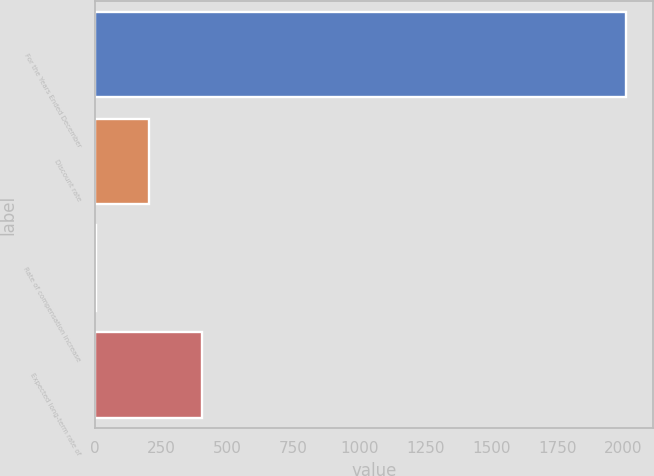Convert chart to OTSL. <chart><loc_0><loc_0><loc_500><loc_500><bar_chart><fcel>For the Years Ended December<fcel>Discount rate<fcel>Rate of compensation increase<fcel>Expected long-term rate of<nl><fcel>2011<fcel>203.48<fcel>2.64<fcel>404.32<nl></chart> 